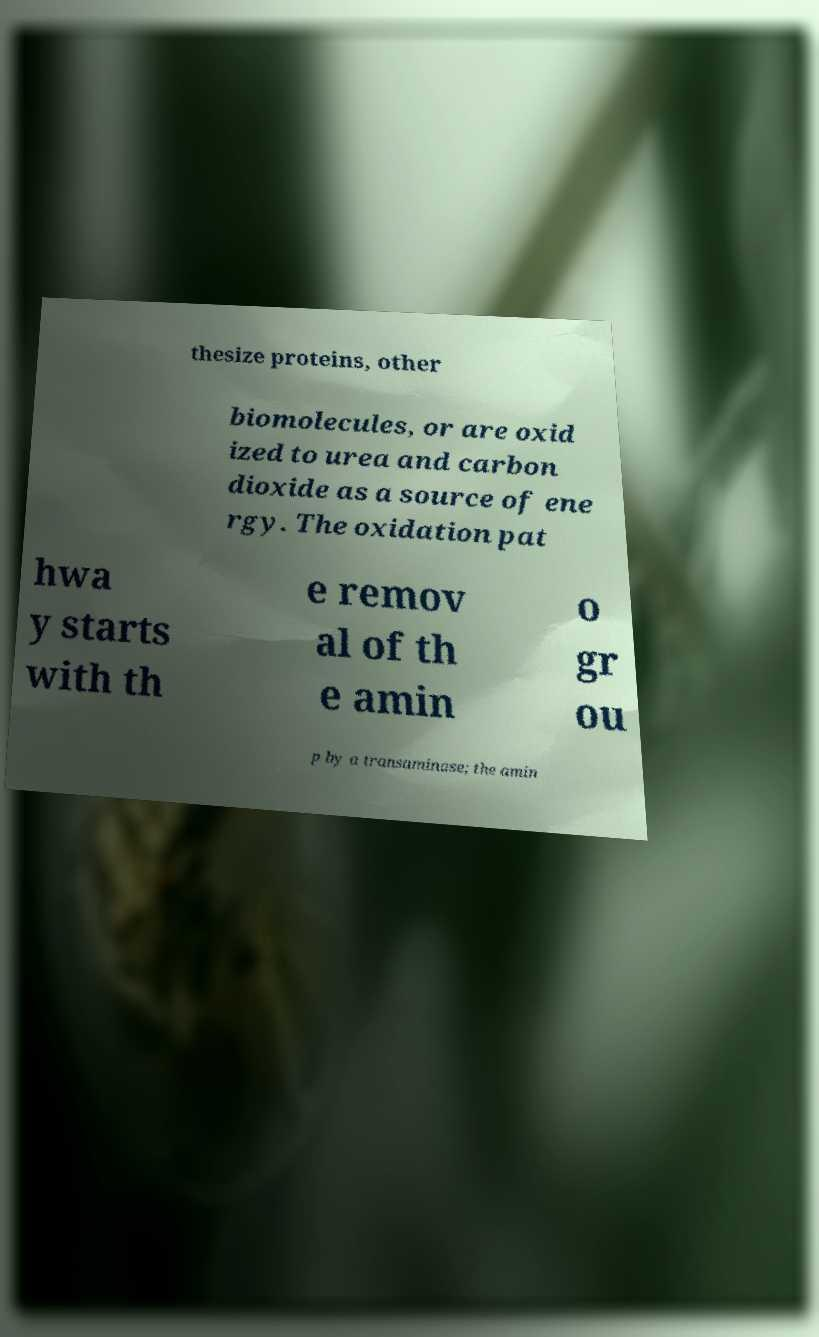Could you assist in decoding the text presented in this image and type it out clearly? thesize proteins, other biomolecules, or are oxid ized to urea and carbon dioxide as a source of ene rgy. The oxidation pat hwa y starts with th e remov al of th e amin o gr ou p by a transaminase; the amin 